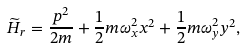<formula> <loc_0><loc_0><loc_500><loc_500>\widetilde { H } _ { r } = \frac { p ^ { 2 } } { 2 m } + \frac { 1 } { 2 } m \omega _ { x } ^ { 2 } x ^ { 2 } + \frac { 1 } { 2 } m \omega _ { y } ^ { 2 } y ^ { 2 } ,</formula> 